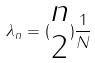Convert formula to latex. <formula><loc_0><loc_0><loc_500><loc_500>\lambda _ { n } = ( \begin{matrix} n \\ 2 \end{matrix} ) \frac { 1 } { N }</formula> 